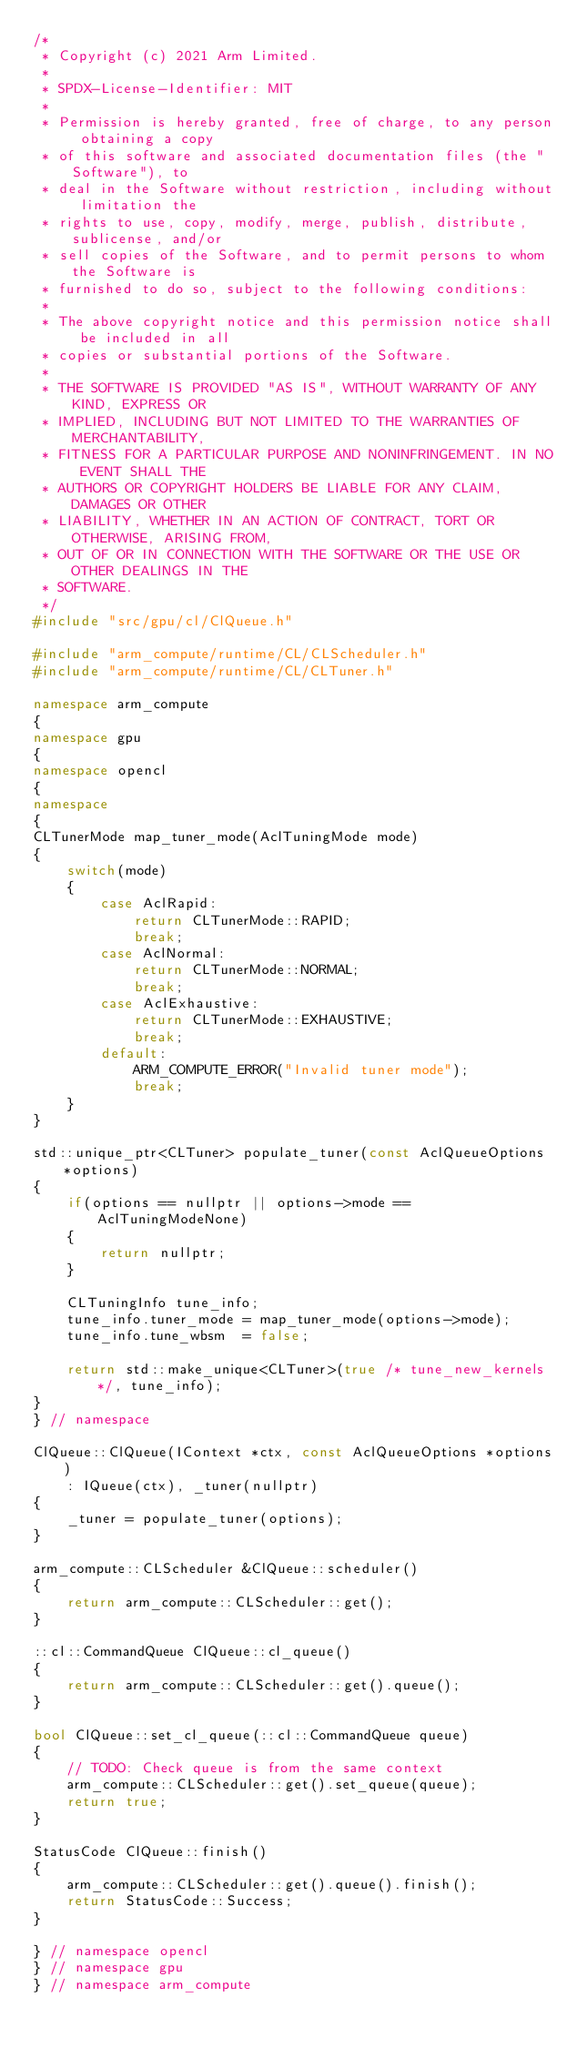Convert code to text. <code><loc_0><loc_0><loc_500><loc_500><_C++_>/*
 * Copyright (c) 2021 Arm Limited.
 *
 * SPDX-License-Identifier: MIT
 *
 * Permission is hereby granted, free of charge, to any person obtaining a copy
 * of this software and associated documentation files (the "Software"), to
 * deal in the Software without restriction, including without limitation the
 * rights to use, copy, modify, merge, publish, distribute, sublicense, and/or
 * sell copies of the Software, and to permit persons to whom the Software is
 * furnished to do so, subject to the following conditions:
 *
 * The above copyright notice and this permission notice shall be included in all
 * copies or substantial portions of the Software.
 *
 * THE SOFTWARE IS PROVIDED "AS IS", WITHOUT WARRANTY OF ANY KIND, EXPRESS OR
 * IMPLIED, INCLUDING BUT NOT LIMITED TO THE WARRANTIES OF MERCHANTABILITY,
 * FITNESS FOR A PARTICULAR PURPOSE AND NONINFRINGEMENT. IN NO EVENT SHALL THE
 * AUTHORS OR COPYRIGHT HOLDERS BE LIABLE FOR ANY CLAIM, DAMAGES OR OTHER
 * LIABILITY, WHETHER IN AN ACTION OF CONTRACT, TORT OR OTHERWISE, ARISING FROM,
 * OUT OF OR IN CONNECTION WITH THE SOFTWARE OR THE USE OR OTHER DEALINGS IN THE
 * SOFTWARE.
 */
#include "src/gpu/cl/ClQueue.h"

#include "arm_compute/runtime/CL/CLScheduler.h"
#include "arm_compute/runtime/CL/CLTuner.h"

namespace arm_compute
{
namespace gpu
{
namespace opencl
{
namespace
{
CLTunerMode map_tuner_mode(AclTuningMode mode)
{
    switch(mode)
    {
        case AclRapid:
            return CLTunerMode::RAPID;
            break;
        case AclNormal:
            return CLTunerMode::NORMAL;
            break;
        case AclExhaustive:
            return CLTunerMode::EXHAUSTIVE;
            break;
        default:
            ARM_COMPUTE_ERROR("Invalid tuner mode");
            break;
    }
}

std::unique_ptr<CLTuner> populate_tuner(const AclQueueOptions *options)
{
    if(options == nullptr || options->mode == AclTuningModeNone)
    {
        return nullptr;
    }

    CLTuningInfo tune_info;
    tune_info.tuner_mode = map_tuner_mode(options->mode);
    tune_info.tune_wbsm  = false;

    return std::make_unique<CLTuner>(true /* tune_new_kernels */, tune_info);
}
} // namespace

ClQueue::ClQueue(IContext *ctx, const AclQueueOptions *options)
    : IQueue(ctx), _tuner(nullptr)
{
    _tuner = populate_tuner(options);
}

arm_compute::CLScheduler &ClQueue::scheduler()
{
    return arm_compute::CLScheduler::get();
}

::cl::CommandQueue ClQueue::cl_queue()
{
    return arm_compute::CLScheduler::get().queue();
}

bool ClQueue::set_cl_queue(::cl::CommandQueue queue)
{
    // TODO: Check queue is from the same context
    arm_compute::CLScheduler::get().set_queue(queue);
    return true;
}

StatusCode ClQueue::finish()
{
    arm_compute::CLScheduler::get().queue().finish();
    return StatusCode::Success;
}

} // namespace opencl
} // namespace gpu
} // namespace arm_compute
</code> 